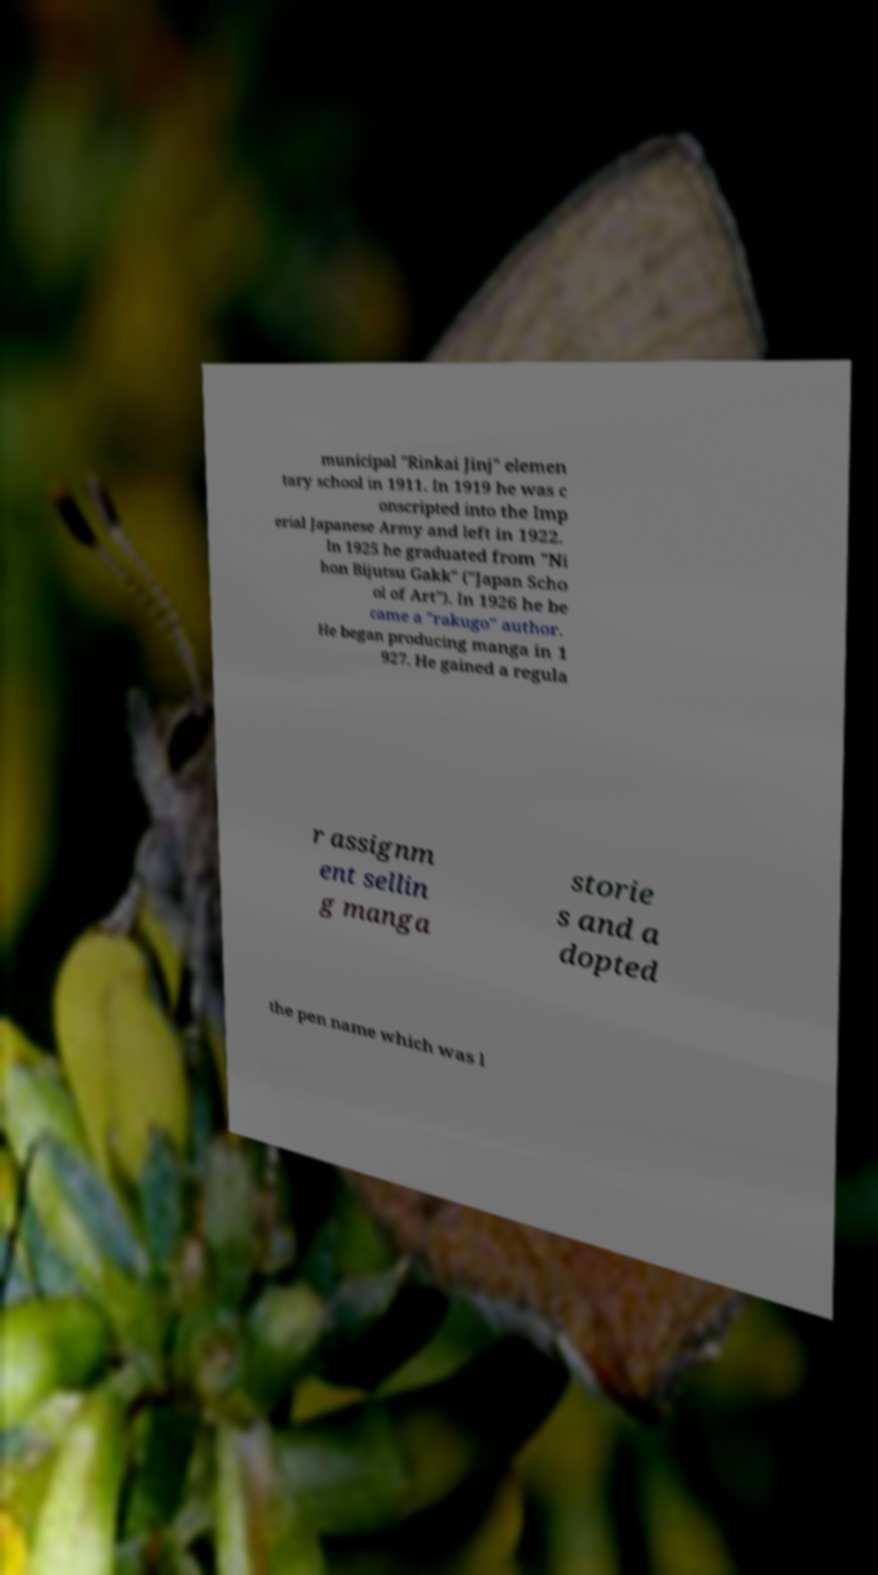What messages or text are displayed in this image? I need them in a readable, typed format. municipal "Rinkai Jinj" elemen tary school in 1911. In 1919 he was c onscripted into the Imp erial Japanese Army and left in 1922. In 1925 he graduated from "Ni hon Bijutsu Gakk" ("Japan Scho ol of Art"). In 1926 he be came a "rakugo" author. He began producing manga in 1 927. He gained a regula r assignm ent sellin g manga storie s and a dopted the pen name which was l 